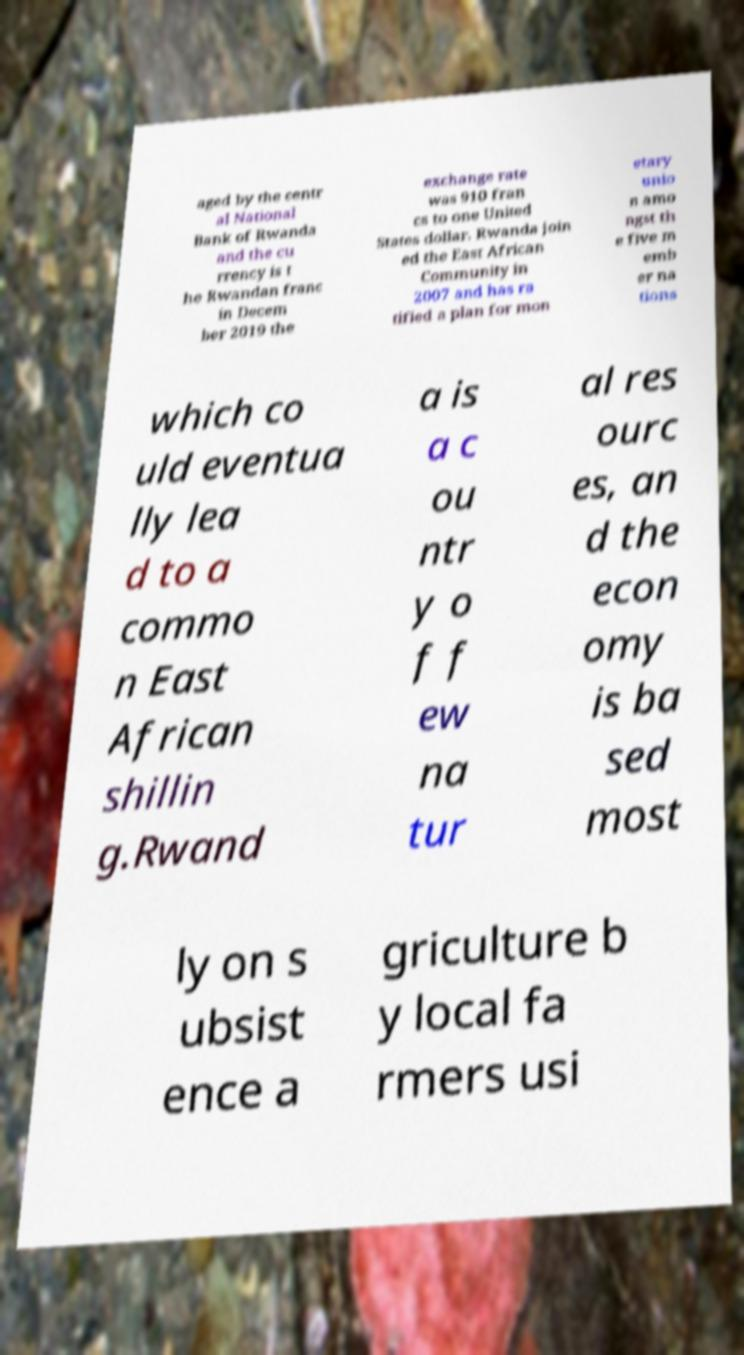There's text embedded in this image that I need extracted. Can you transcribe it verbatim? aged by the centr al National Bank of Rwanda and the cu rrency is t he Rwandan franc in Decem ber 2019 the exchange rate was 910 fran cs to one United States dollar. Rwanda join ed the East African Community in 2007 and has ra tified a plan for mon etary unio n amo ngst th e five m emb er na tions which co uld eventua lly lea d to a commo n East African shillin g.Rwand a is a c ou ntr y o f f ew na tur al res ourc es, an d the econ omy is ba sed most ly on s ubsist ence a griculture b y local fa rmers usi 